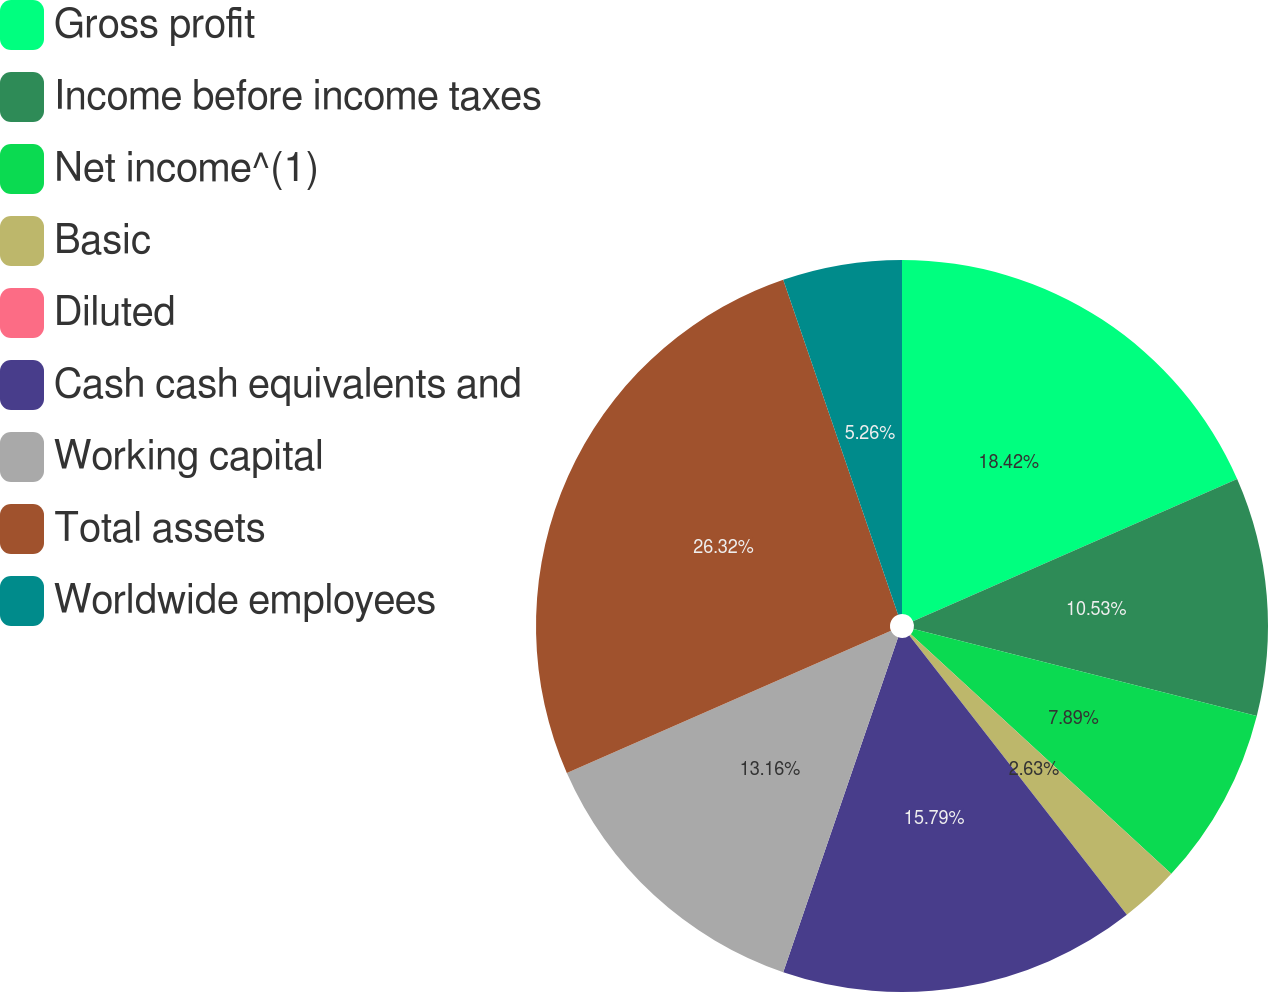Convert chart. <chart><loc_0><loc_0><loc_500><loc_500><pie_chart><fcel>Gross profit<fcel>Income before income taxes<fcel>Net income^(1)<fcel>Basic<fcel>Diluted<fcel>Cash cash equivalents and<fcel>Working capital<fcel>Total assets<fcel>Worldwide employees<nl><fcel>18.42%<fcel>10.53%<fcel>7.89%<fcel>2.63%<fcel>0.0%<fcel>15.79%<fcel>13.16%<fcel>26.32%<fcel>5.26%<nl></chart> 